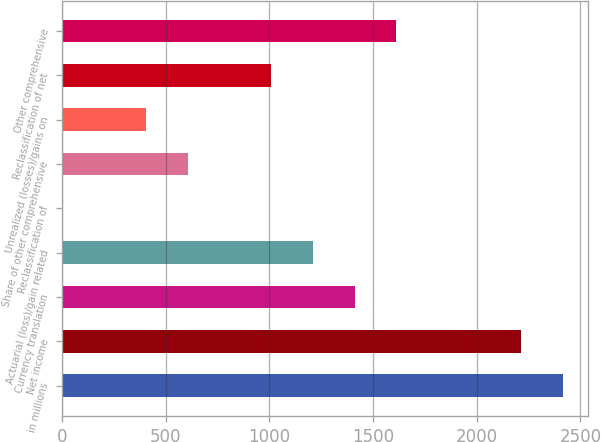<chart> <loc_0><loc_0><loc_500><loc_500><bar_chart><fcel>in millions<fcel>Net income<fcel>Currency translation<fcel>Actuarial (loss)/gain related<fcel>Reclassification of<fcel>Share of other comprehensive<fcel>Unrealized (losses)/gains on<fcel>Reclassification of net<fcel>Other comprehensive<nl><fcel>2416.52<fcel>2215.26<fcel>1410.22<fcel>1208.96<fcel>1.4<fcel>605.18<fcel>403.92<fcel>1007.7<fcel>1611.48<nl></chart> 